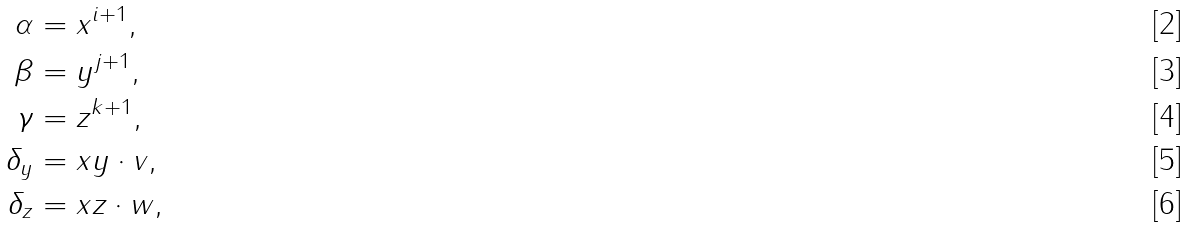<formula> <loc_0><loc_0><loc_500><loc_500>\alpha & = x ^ { i + 1 } , \\ \beta & = y ^ { j + 1 } , \\ \gamma & = z ^ { k + 1 } , \\ \delta _ { y } & = x y \cdot v , \\ \delta _ { z } & = x z \cdot w ,</formula> 